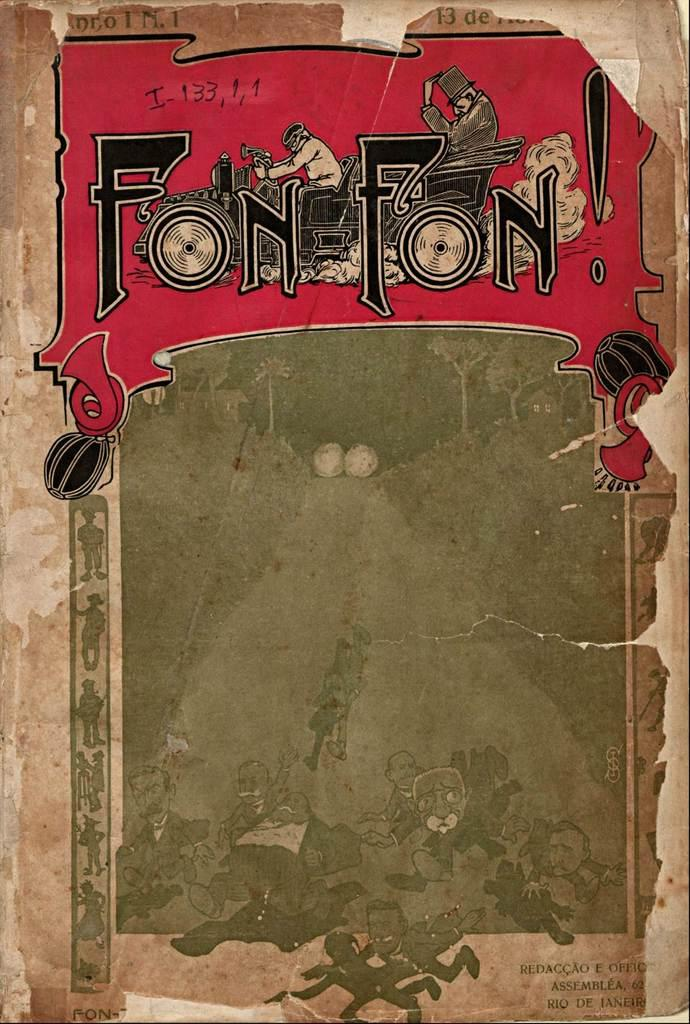What is the main subject of the image? The main subject of the image is the cover page of a book. What elements are present on the cover page? The cover page contains images and text. What part of the giraffe is visible on the cover page? There is no giraffe present on the cover page; it only contains images and text related to the book. 